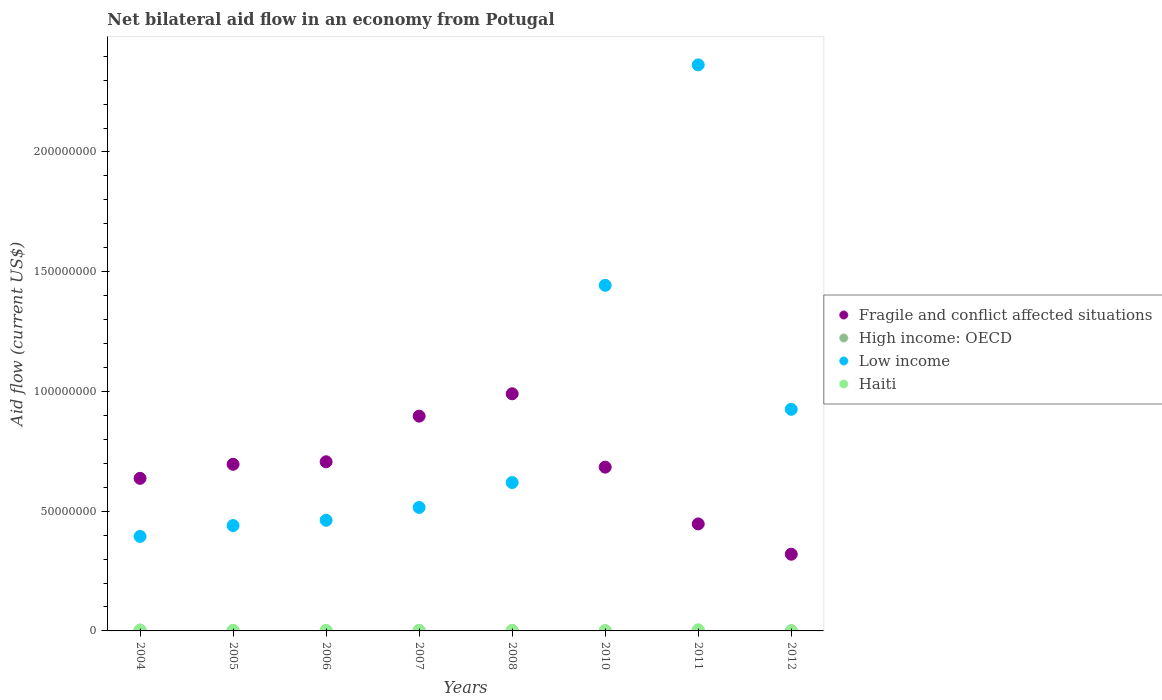How many different coloured dotlines are there?
Ensure brevity in your answer.  4. Is the number of dotlines equal to the number of legend labels?
Make the answer very short. Yes. What is the net bilateral aid flow in High income: OECD in 2008?
Provide a succinct answer. 1.00e+05. Across all years, what is the maximum net bilateral aid flow in Fragile and conflict affected situations?
Give a very brief answer. 9.90e+07. Across all years, what is the minimum net bilateral aid flow in Low income?
Offer a terse response. 3.94e+07. In which year was the net bilateral aid flow in Haiti maximum?
Your response must be concise. 2011. What is the total net bilateral aid flow in High income: OECD in the graph?
Offer a terse response. 9.10e+05. What is the difference between the net bilateral aid flow in Haiti in 2010 and that in 2011?
Ensure brevity in your answer.  -3.60e+05. What is the difference between the net bilateral aid flow in Low income in 2004 and the net bilateral aid flow in Fragile and conflict affected situations in 2005?
Offer a terse response. -3.01e+07. What is the average net bilateral aid flow in Fragile and conflict affected situations per year?
Provide a succinct answer. 6.72e+07. In the year 2011, what is the difference between the net bilateral aid flow in High income: OECD and net bilateral aid flow in Haiti?
Make the answer very short. -3.80e+05. In how many years, is the net bilateral aid flow in Low income greater than 140000000 US$?
Your response must be concise. 2. What is the ratio of the net bilateral aid flow in High income: OECD in 2004 to that in 2011?
Offer a terse response. 3.78. What is the difference between the highest and the second highest net bilateral aid flow in Fragile and conflict affected situations?
Your answer should be very brief. 9.33e+06. What is the difference between the highest and the lowest net bilateral aid flow in Low income?
Provide a short and direct response. 1.97e+08. In how many years, is the net bilateral aid flow in Low income greater than the average net bilateral aid flow in Low income taken over all years?
Provide a succinct answer. 3. Is the sum of the net bilateral aid flow in Haiti in 2010 and 2012 greater than the maximum net bilateral aid flow in Low income across all years?
Your response must be concise. No. Does the net bilateral aid flow in Haiti monotonically increase over the years?
Your answer should be compact. No. Is the net bilateral aid flow in Haiti strictly greater than the net bilateral aid flow in Fragile and conflict affected situations over the years?
Your response must be concise. No. How many dotlines are there?
Provide a short and direct response. 4. How many years are there in the graph?
Make the answer very short. 8. What is the difference between two consecutive major ticks on the Y-axis?
Your answer should be very brief. 5.00e+07. Are the values on the major ticks of Y-axis written in scientific E-notation?
Keep it short and to the point. No. Does the graph contain any zero values?
Your response must be concise. No. Where does the legend appear in the graph?
Ensure brevity in your answer.  Center right. What is the title of the graph?
Your answer should be very brief. Net bilateral aid flow in an economy from Potugal. What is the label or title of the Y-axis?
Offer a terse response. Aid flow (current US$). What is the Aid flow (current US$) in Fragile and conflict affected situations in 2004?
Keep it short and to the point. 6.37e+07. What is the Aid flow (current US$) in Low income in 2004?
Offer a very short reply. 3.94e+07. What is the Aid flow (current US$) in Fragile and conflict affected situations in 2005?
Provide a succinct answer. 6.96e+07. What is the Aid flow (current US$) in Low income in 2005?
Give a very brief answer. 4.40e+07. What is the Aid flow (current US$) in Fragile and conflict affected situations in 2006?
Your response must be concise. 7.06e+07. What is the Aid flow (current US$) in High income: OECD in 2006?
Offer a very short reply. 9.00e+04. What is the Aid flow (current US$) in Low income in 2006?
Provide a succinct answer. 4.62e+07. What is the Aid flow (current US$) in Fragile and conflict affected situations in 2007?
Your response must be concise. 8.97e+07. What is the Aid flow (current US$) in High income: OECD in 2007?
Your response must be concise. 1.30e+05. What is the Aid flow (current US$) in Low income in 2007?
Keep it short and to the point. 5.16e+07. What is the Aid flow (current US$) of Haiti in 2007?
Ensure brevity in your answer.  1.70e+05. What is the Aid flow (current US$) in Fragile and conflict affected situations in 2008?
Ensure brevity in your answer.  9.90e+07. What is the Aid flow (current US$) in Low income in 2008?
Provide a short and direct response. 6.20e+07. What is the Aid flow (current US$) in Haiti in 2008?
Offer a terse response. 1.80e+05. What is the Aid flow (current US$) in Fragile and conflict affected situations in 2010?
Offer a very short reply. 6.84e+07. What is the Aid flow (current US$) of Low income in 2010?
Make the answer very short. 1.44e+08. What is the Aid flow (current US$) in Haiti in 2010?
Make the answer very short. 1.10e+05. What is the Aid flow (current US$) in Fragile and conflict affected situations in 2011?
Keep it short and to the point. 4.47e+07. What is the Aid flow (current US$) of High income: OECD in 2011?
Your answer should be compact. 9.00e+04. What is the Aid flow (current US$) of Low income in 2011?
Ensure brevity in your answer.  2.36e+08. What is the Aid flow (current US$) in Fragile and conflict affected situations in 2012?
Keep it short and to the point. 3.20e+07. What is the Aid flow (current US$) of Low income in 2012?
Your response must be concise. 9.25e+07. What is the Aid flow (current US$) in Haiti in 2012?
Give a very brief answer. 10000. Across all years, what is the maximum Aid flow (current US$) in Fragile and conflict affected situations?
Offer a terse response. 9.90e+07. Across all years, what is the maximum Aid flow (current US$) in High income: OECD?
Make the answer very short. 3.40e+05. Across all years, what is the maximum Aid flow (current US$) in Low income?
Offer a very short reply. 2.36e+08. Across all years, what is the maximum Aid flow (current US$) of Haiti?
Ensure brevity in your answer.  4.70e+05. Across all years, what is the minimum Aid flow (current US$) in Fragile and conflict affected situations?
Offer a terse response. 3.20e+07. Across all years, what is the minimum Aid flow (current US$) of High income: OECD?
Your response must be concise. 4.00e+04. Across all years, what is the minimum Aid flow (current US$) in Low income?
Give a very brief answer. 3.94e+07. Across all years, what is the minimum Aid flow (current US$) in Haiti?
Make the answer very short. 10000. What is the total Aid flow (current US$) of Fragile and conflict affected situations in the graph?
Your response must be concise. 5.38e+08. What is the total Aid flow (current US$) of High income: OECD in the graph?
Your answer should be very brief. 9.10e+05. What is the total Aid flow (current US$) of Low income in the graph?
Offer a terse response. 7.16e+08. What is the total Aid flow (current US$) in Haiti in the graph?
Your answer should be compact. 1.64e+06. What is the difference between the Aid flow (current US$) of Fragile and conflict affected situations in 2004 and that in 2005?
Your answer should be compact. -5.87e+06. What is the difference between the Aid flow (current US$) in Low income in 2004 and that in 2005?
Your answer should be very brief. -4.55e+06. What is the difference between the Aid flow (current US$) of Haiti in 2004 and that in 2005?
Your response must be concise. 4.00e+04. What is the difference between the Aid flow (current US$) in Fragile and conflict affected situations in 2004 and that in 2006?
Offer a terse response. -6.92e+06. What is the difference between the Aid flow (current US$) of High income: OECD in 2004 and that in 2006?
Provide a succinct answer. 2.50e+05. What is the difference between the Aid flow (current US$) in Low income in 2004 and that in 2006?
Give a very brief answer. -6.76e+06. What is the difference between the Aid flow (current US$) of Fragile and conflict affected situations in 2004 and that in 2007?
Your answer should be very brief. -2.60e+07. What is the difference between the Aid flow (current US$) of High income: OECD in 2004 and that in 2007?
Provide a succinct answer. 2.10e+05. What is the difference between the Aid flow (current US$) in Low income in 2004 and that in 2007?
Give a very brief answer. -1.21e+07. What is the difference between the Aid flow (current US$) in Haiti in 2004 and that in 2007?
Give a very brief answer. 1.20e+05. What is the difference between the Aid flow (current US$) in Fragile and conflict affected situations in 2004 and that in 2008?
Offer a very short reply. -3.53e+07. What is the difference between the Aid flow (current US$) of High income: OECD in 2004 and that in 2008?
Offer a terse response. 2.40e+05. What is the difference between the Aid flow (current US$) in Low income in 2004 and that in 2008?
Offer a very short reply. -2.25e+07. What is the difference between the Aid flow (current US$) in Fragile and conflict affected situations in 2004 and that in 2010?
Ensure brevity in your answer.  -4.68e+06. What is the difference between the Aid flow (current US$) in High income: OECD in 2004 and that in 2010?
Provide a succinct answer. 3.00e+05. What is the difference between the Aid flow (current US$) in Low income in 2004 and that in 2010?
Ensure brevity in your answer.  -1.05e+08. What is the difference between the Aid flow (current US$) of Haiti in 2004 and that in 2010?
Your answer should be compact. 1.80e+05. What is the difference between the Aid flow (current US$) in Fragile and conflict affected situations in 2004 and that in 2011?
Make the answer very short. 1.90e+07. What is the difference between the Aid flow (current US$) of Low income in 2004 and that in 2011?
Offer a very short reply. -1.97e+08. What is the difference between the Aid flow (current US$) of Haiti in 2004 and that in 2011?
Offer a very short reply. -1.80e+05. What is the difference between the Aid flow (current US$) of Fragile and conflict affected situations in 2004 and that in 2012?
Provide a short and direct response. 3.17e+07. What is the difference between the Aid flow (current US$) of High income: OECD in 2004 and that in 2012?
Ensure brevity in your answer.  2.70e+05. What is the difference between the Aid flow (current US$) in Low income in 2004 and that in 2012?
Provide a succinct answer. -5.31e+07. What is the difference between the Aid flow (current US$) of Haiti in 2004 and that in 2012?
Your answer should be compact. 2.80e+05. What is the difference between the Aid flow (current US$) in Fragile and conflict affected situations in 2005 and that in 2006?
Make the answer very short. -1.05e+06. What is the difference between the Aid flow (current US$) of High income: OECD in 2005 and that in 2006?
Ensure brevity in your answer.  -4.00e+04. What is the difference between the Aid flow (current US$) of Low income in 2005 and that in 2006?
Offer a very short reply. -2.21e+06. What is the difference between the Aid flow (current US$) of Fragile and conflict affected situations in 2005 and that in 2007?
Give a very brief answer. -2.01e+07. What is the difference between the Aid flow (current US$) of Low income in 2005 and that in 2007?
Your answer should be compact. -7.56e+06. What is the difference between the Aid flow (current US$) in Haiti in 2005 and that in 2007?
Make the answer very short. 8.00e+04. What is the difference between the Aid flow (current US$) of Fragile and conflict affected situations in 2005 and that in 2008?
Provide a succinct answer. -2.94e+07. What is the difference between the Aid flow (current US$) of Low income in 2005 and that in 2008?
Your answer should be very brief. -1.80e+07. What is the difference between the Aid flow (current US$) in Haiti in 2005 and that in 2008?
Your answer should be very brief. 7.00e+04. What is the difference between the Aid flow (current US$) in Fragile and conflict affected situations in 2005 and that in 2010?
Give a very brief answer. 1.19e+06. What is the difference between the Aid flow (current US$) in Low income in 2005 and that in 2010?
Make the answer very short. -1.00e+08. What is the difference between the Aid flow (current US$) of Fragile and conflict affected situations in 2005 and that in 2011?
Keep it short and to the point. 2.49e+07. What is the difference between the Aid flow (current US$) of Low income in 2005 and that in 2011?
Offer a terse response. -1.92e+08. What is the difference between the Aid flow (current US$) in Fragile and conflict affected situations in 2005 and that in 2012?
Provide a succinct answer. 3.76e+07. What is the difference between the Aid flow (current US$) in Low income in 2005 and that in 2012?
Offer a very short reply. -4.85e+07. What is the difference between the Aid flow (current US$) in Haiti in 2005 and that in 2012?
Offer a very short reply. 2.40e+05. What is the difference between the Aid flow (current US$) in Fragile and conflict affected situations in 2006 and that in 2007?
Keep it short and to the point. -1.91e+07. What is the difference between the Aid flow (current US$) in High income: OECD in 2006 and that in 2007?
Keep it short and to the point. -4.00e+04. What is the difference between the Aid flow (current US$) in Low income in 2006 and that in 2007?
Offer a very short reply. -5.35e+06. What is the difference between the Aid flow (current US$) in Fragile and conflict affected situations in 2006 and that in 2008?
Your answer should be very brief. -2.84e+07. What is the difference between the Aid flow (current US$) in Low income in 2006 and that in 2008?
Give a very brief answer. -1.58e+07. What is the difference between the Aid flow (current US$) of Haiti in 2006 and that in 2008?
Your response must be concise. -2.00e+04. What is the difference between the Aid flow (current US$) in Fragile and conflict affected situations in 2006 and that in 2010?
Keep it short and to the point. 2.24e+06. What is the difference between the Aid flow (current US$) in High income: OECD in 2006 and that in 2010?
Provide a short and direct response. 5.00e+04. What is the difference between the Aid flow (current US$) in Low income in 2006 and that in 2010?
Ensure brevity in your answer.  -9.81e+07. What is the difference between the Aid flow (current US$) of Fragile and conflict affected situations in 2006 and that in 2011?
Your response must be concise. 2.60e+07. What is the difference between the Aid flow (current US$) in High income: OECD in 2006 and that in 2011?
Offer a very short reply. 0. What is the difference between the Aid flow (current US$) of Low income in 2006 and that in 2011?
Ensure brevity in your answer.  -1.90e+08. What is the difference between the Aid flow (current US$) in Haiti in 2006 and that in 2011?
Your response must be concise. -3.10e+05. What is the difference between the Aid flow (current US$) of Fragile and conflict affected situations in 2006 and that in 2012?
Keep it short and to the point. 3.86e+07. What is the difference between the Aid flow (current US$) of High income: OECD in 2006 and that in 2012?
Offer a very short reply. 2.00e+04. What is the difference between the Aid flow (current US$) of Low income in 2006 and that in 2012?
Give a very brief answer. -4.63e+07. What is the difference between the Aid flow (current US$) of Haiti in 2006 and that in 2012?
Ensure brevity in your answer.  1.50e+05. What is the difference between the Aid flow (current US$) of Fragile and conflict affected situations in 2007 and that in 2008?
Make the answer very short. -9.33e+06. What is the difference between the Aid flow (current US$) of Low income in 2007 and that in 2008?
Your response must be concise. -1.04e+07. What is the difference between the Aid flow (current US$) in Haiti in 2007 and that in 2008?
Provide a succinct answer. -10000. What is the difference between the Aid flow (current US$) of Fragile and conflict affected situations in 2007 and that in 2010?
Provide a succinct answer. 2.13e+07. What is the difference between the Aid flow (current US$) in Low income in 2007 and that in 2010?
Offer a very short reply. -9.28e+07. What is the difference between the Aid flow (current US$) of Fragile and conflict affected situations in 2007 and that in 2011?
Provide a succinct answer. 4.50e+07. What is the difference between the Aid flow (current US$) in Low income in 2007 and that in 2011?
Make the answer very short. -1.85e+08. What is the difference between the Aid flow (current US$) in Haiti in 2007 and that in 2011?
Offer a terse response. -3.00e+05. What is the difference between the Aid flow (current US$) in Fragile and conflict affected situations in 2007 and that in 2012?
Keep it short and to the point. 5.77e+07. What is the difference between the Aid flow (current US$) of Low income in 2007 and that in 2012?
Offer a very short reply. -4.10e+07. What is the difference between the Aid flow (current US$) in Fragile and conflict affected situations in 2008 and that in 2010?
Your answer should be very brief. 3.06e+07. What is the difference between the Aid flow (current US$) of Low income in 2008 and that in 2010?
Your answer should be compact. -8.23e+07. What is the difference between the Aid flow (current US$) in Haiti in 2008 and that in 2010?
Provide a succinct answer. 7.00e+04. What is the difference between the Aid flow (current US$) in Fragile and conflict affected situations in 2008 and that in 2011?
Ensure brevity in your answer.  5.43e+07. What is the difference between the Aid flow (current US$) in Low income in 2008 and that in 2011?
Make the answer very short. -1.74e+08. What is the difference between the Aid flow (current US$) in Fragile and conflict affected situations in 2008 and that in 2012?
Provide a succinct answer. 6.70e+07. What is the difference between the Aid flow (current US$) in Low income in 2008 and that in 2012?
Provide a short and direct response. -3.06e+07. What is the difference between the Aid flow (current US$) in Fragile and conflict affected situations in 2010 and that in 2011?
Keep it short and to the point. 2.37e+07. What is the difference between the Aid flow (current US$) in Low income in 2010 and that in 2011?
Make the answer very short. -9.20e+07. What is the difference between the Aid flow (current US$) in Haiti in 2010 and that in 2011?
Provide a succinct answer. -3.60e+05. What is the difference between the Aid flow (current US$) of Fragile and conflict affected situations in 2010 and that in 2012?
Provide a succinct answer. 3.64e+07. What is the difference between the Aid flow (current US$) in Low income in 2010 and that in 2012?
Your answer should be compact. 5.18e+07. What is the difference between the Aid flow (current US$) of Fragile and conflict affected situations in 2011 and that in 2012?
Keep it short and to the point. 1.26e+07. What is the difference between the Aid flow (current US$) of High income: OECD in 2011 and that in 2012?
Your response must be concise. 2.00e+04. What is the difference between the Aid flow (current US$) of Low income in 2011 and that in 2012?
Your answer should be compact. 1.44e+08. What is the difference between the Aid flow (current US$) in Fragile and conflict affected situations in 2004 and the Aid flow (current US$) in High income: OECD in 2005?
Give a very brief answer. 6.37e+07. What is the difference between the Aid flow (current US$) of Fragile and conflict affected situations in 2004 and the Aid flow (current US$) of Low income in 2005?
Your answer should be very brief. 1.97e+07. What is the difference between the Aid flow (current US$) in Fragile and conflict affected situations in 2004 and the Aid flow (current US$) in Haiti in 2005?
Provide a succinct answer. 6.35e+07. What is the difference between the Aid flow (current US$) in High income: OECD in 2004 and the Aid flow (current US$) in Low income in 2005?
Offer a terse response. -4.37e+07. What is the difference between the Aid flow (current US$) in High income: OECD in 2004 and the Aid flow (current US$) in Haiti in 2005?
Your response must be concise. 9.00e+04. What is the difference between the Aid flow (current US$) in Low income in 2004 and the Aid flow (current US$) in Haiti in 2005?
Provide a short and direct response. 3.92e+07. What is the difference between the Aid flow (current US$) of Fragile and conflict affected situations in 2004 and the Aid flow (current US$) of High income: OECD in 2006?
Offer a terse response. 6.36e+07. What is the difference between the Aid flow (current US$) in Fragile and conflict affected situations in 2004 and the Aid flow (current US$) in Low income in 2006?
Keep it short and to the point. 1.75e+07. What is the difference between the Aid flow (current US$) in Fragile and conflict affected situations in 2004 and the Aid flow (current US$) in Haiti in 2006?
Your response must be concise. 6.36e+07. What is the difference between the Aid flow (current US$) in High income: OECD in 2004 and the Aid flow (current US$) in Low income in 2006?
Give a very brief answer. -4.59e+07. What is the difference between the Aid flow (current US$) in Low income in 2004 and the Aid flow (current US$) in Haiti in 2006?
Provide a short and direct response. 3.93e+07. What is the difference between the Aid flow (current US$) of Fragile and conflict affected situations in 2004 and the Aid flow (current US$) of High income: OECD in 2007?
Make the answer very short. 6.36e+07. What is the difference between the Aid flow (current US$) of Fragile and conflict affected situations in 2004 and the Aid flow (current US$) of Low income in 2007?
Offer a very short reply. 1.22e+07. What is the difference between the Aid flow (current US$) of Fragile and conflict affected situations in 2004 and the Aid flow (current US$) of Haiti in 2007?
Offer a terse response. 6.35e+07. What is the difference between the Aid flow (current US$) in High income: OECD in 2004 and the Aid flow (current US$) in Low income in 2007?
Ensure brevity in your answer.  -5.12e+07. What is the difference between the Aid flow (current US$) in Low income in 2004 and the Aid flow (current US$) in Haiti in 2007?
Your answer should be very brief. 3.93e+07. What is the difference between the Aid flow (current US$) of Fragile and conflict affected situations in 2004 and the Aid flow (current US$) of High income: OECD in 2008?
Your response must be concise. 6.36e+07. What is the difference between the Aid flow (current US$) of Fragile and conflict affected situations in 2004 and the Aid flow (current US$) of Low income in 2008?
Your answer should be very brief. 1.73e+06. What is the difference between the Aid flow (current US$) of Fragile and conflict affected situations in 2004 and the Aid flow (current US$) of Haiti in 2008?
Give a very brief answer. 6.35e+07. What is the difference between the Aid flow (current US$) of High income: OECD in 2004 and the Aid flow (current US$) of Low income in 2008?
Your answer should be compact. -6.16e+07. What is the difference between the Aid flow (current US$) of High income: OECD in 2004 and the Aid flow (current US$) of Haiti in 2008?
Your answer should be very brief. 1.60e+05. What is the difference between the Aid flow (current US$) in Low income in 2004 and the Aid flow (current US$) in Haiti in 2008?
Your response must be concise. 3.93e+07. What is the difference between the Aid flow (current US$) of Fragile and conflict affected situations in 2004 and the Aid flow (current US$) of High income: OECD in 2010?
Offer a very short reply. 6.37e+07. What is the difference between the Aid flow (current US$) in Fragile and conflict affected situations in 2004 and the Aid flow (current US$) in Low income in 2010?
Offer a terse response. -8.06e+07. What is the difference between the Aid flow (current US$) in Fragile and conflict affected situations in 2004 and the Aid flow (current US$) in Haiti in 2010?
Make the answer very short. 6.36e+07. What is the difference between the Aid flow (current US$) in High income: OECD in 2004 and the Aid flow (current US$) in Low income in 2010?
Ensure brevity in your answer.  -1.44e+08. What is the difference between the Aid flow (current US$) of High income: OECD in 2004 and the Aid flow (current US$) of Haiti in 2010?
Give a very brief answer. 2.30e+05. What is the difference between the Aid flow (current US$) in Low income in 2004 and the Aid flow (current US$) in Haiti in 2010?
Keep it short and to the point. 3.93e+07. What is the difference between the Aid flow (current US$) in Fragile and conflict affected situations in 2004 and the Aid flow (current US$) in High income: OECD in 2011?
Offer a terse response. 6.36e+07. What is the difference between the Aid flow (current US$) of Fragile and conflict affected situations in 2004 and the Aid flow (current US$) of Low income in 2011?
Keep it short and to the point. -1.73e+08. What is the difference between the Aid flow (current US$) in Fragile and conflict affected situations in 2004 and the Aid flow (current US$) in Haiti in 2011?
Make the answer very short. 6.32e+07. What is the difference between the Aid flow (current US$) in High income: OECD in 2004 and the Aid flow (current US$) in Low income in 2011?
Provide a succinct answer. -2.36e+08. What is the difference between the Aid flow (current US$) in Low income in 2004 and the Aid flow (current US$) in Haiti in 2011?
Your answer should be compact. 3.90e+07. What is the difference between the Aid flow (current US$) in Fragile and conflict affected situations in 2004 and the Aid flow (current US$) in High income: OECD in 2012?
Offer a terse response. 6.36e+07. What is the difference between the Aid flow (current US$) in Fragile and conflict affected situations in 2004 and the Aid flow (current US$) in Low income in 2012?
Provide a short and direct response. -2.88e+07. What is the difference between the Aid flow (current US$) of Fragile and conflict affected situations in 2004 and the Aid flow (current US$) of Haiti in 2012?
Offer a very short reply. 6.37e+07. What is the difference between the Aid flow (current US$) of High income: OECD in 2004 and the Aid flow (current US$) of Low income in 2012?
Provide a succinct answer. -9.22e+07. What is the difference between the Aid flow (current US$) in Low income in 2004 and the Aid flow (current US$) in Haiti in 2012?
Give a very brief answer. 3.94e+07. What is the difference between the Aid flow (current US$) in Fragile and conflict affected situations in 2005 and the Aid flow (current US$) in High income: OECD in 2006?
Offer a terse response. 6.95e+07. What is the difference between the Aid flow (current US$) of Fragile and conflict affected situations in 2005 and the Aid flow (current US$) of Low income in 2006?
Provide a succinct answer. 2.34e+07. What is the difference between the Aid flow (current US$) of Fragile and conflict affected situations in 2005 and the Aid flow (current US$) of Haiti in 2006?
Your answer should be very brief. 6.94e+07. What is the difference between the Aid flow (current US$) of High income: OECD in 2005 and the Aid flow (current US$) of Low income in 2006?
Keep it short and to the point. -4.62e+07. What is the difference between the Aid flow (current US$) in Low income in 2005 and the Aid flow (current US$) in Haiti in 2006?
Offer a terse response. 4.38e+07. What is the difference between the Aid flow (current US$) of Fragile and conflict affected situations in 2005 and the Aid flow (current US$) of High income: OECD in 2007?
Your answer should be compact. 6.94e+07. What is the difference between the Aid flow (current US$) in Fragile and conflict affected situations in 2005 and the Aid flow (current US$) in Low income in 2007?
Give a very brief answer. 1.80e+07. What is the difference between the Aid flow (current US$) of Fragile and conflict affected situations in 2005 and the Aid flow (current US$) of Haiti in 2007?
Your response must be concise. 6.94e+07. What is the difference between the Aid flow (current US$) in High income: OECD in 2005 and the Aid flow (current US$) in Low income in 2007?
Offer a very short reply. -5.15e+07. What is the difference between the Aid flow (current US$) of High income: OECD in 2005 and the Aid flow (current US$) of Haiti in 2007?
Give a very brief answer. -1.20e+05. What is the difference between the Aid flow (current US$) of Low income in 2005 and the Aid flow (current US$) of Haiti in 2007?
Provide a short and direct response. 4.38e+07. What is the difference between the Aid flow (current US$) of Fragile and conflict affected situations in 2005 and the Aid flow (current US$) of High income: OECD in 2008?
Your answer should be very brief. 6.95e+07. What is the difference between the Aid flow (current US$) of Fragile and conflict affected situations in 2005 and the Aid flow (current US$) of Low income in 2008?
Your answer should be very brief. 7.60e+06. What is the difference between the Aid flow (current US$) of Fragile and conflict affected situations in 2005 and the Aid flow (current US$) of Haiti in 2008?
Your response must be concise. 6.94e+07. What is the difference between the Aid flow (current US$) in High income: OECD in 2005 and the Aid flow (current US$) in Low income in 2008?
Make the answer very short. -6.19e+07. What is the difference between the Aid flow (current US$) of High income: OECD in 2005 and the Aid flow (current US$) of Haiti in 2008?
Your response must be concise. -1.30e+05. What is the difference between the Aid flow (current US$) in Low income in 2005 and the Aid flow (current US$) in Haiti in 2008?
Provide a succinct answer. 4.38e+07. What is the difference between the Aid flow (current US$) of Fragile and conflict affected situations in 2005 and the Aid flow (current US$) of High income: OECD in 2010?
Offer a very short reply. 6.95e+07. What is the difference between the Aid flow (current US$) in Fragile and conflict affected situations in 2005 and the Aid flow (current US$) in Low income in 2010?
Your answer should be compact. -7.47e+07. What is the difference between the Aid flow (current US$) in Fragile and conflict affected situations in 2005 and the Aid flow (current US$) in Haiti in 2010?
Provide a succinct answer. 6.95e+07. What is the difference between the Aid flow (current US$) of High income: OECD in 2005 and the Aid flow (current US$) of Low income in 2010?
Give a very brief answer. -1.44e+08. What is the difference between the Aid flow (current US$) in High income: OECD in 2005 and the Aid flow (current US$) in Haiti in 2010?
Offer a very short reply. -6.00e+04. What is the difference between the Aid flow (current US$) of Low income in 2005 and the Aid flow (current US$) of Haiti in 2010?
Provide a succinct answer. 4.39e+07. What is the difference between the Aid flow (current US$) of Fragile and conflict affected situations in 2005 and the Aid flow (current US$) of High income: OECD in 2011?
Your response must be concise. 6.95e+07. What is the difference between the Aid flow (current US$) of Fragile and conflict affected situations in 2005 and the Aid flow (current US$) of Low income in 2011?
Your answer should be very brief. -1.67e+08. What is the difference between the Aid flow (current US$) in Fragile and conflict affected situations in 2005 and the Aid flow (current US$) in Haiti in 2011?
Your answer should be compact. 6.91e+07. What is the difference between the Aid flow (current US$) of High income: OECD in 2005 and the Aid flow (current US$) of Low income in 2011?
Your answer should be very brief. -2.36e+08. What is the difference between the Aid flow (current US$) of High income: OECD in 2005 and the Aid flow (current US$) of Haiti in 2011?
Your answer should be compact. -4.20e+05. What is the difference between the Aid flow (current US$) of Low income in 2005 and the Aid flow (current US$) of Haiti in 2011?
Your answer should be compact. 4.35e+07. What is the difference between the Aid flow (current US$) in Fragile and conflict affected situations in 2005 and the Aid flow (current US$) in High income: OECD in 2012?
Provide a short and direct response. 6.95e+07. What is the difference between the Aid flow (current US$) in Fragile and conflict affected situations in 2005 and the Aid flow (current US$) in Low income in 2012?
Your response must be concise. -2.30e+07. What is the difference between the Aid flow (current US$) of Fragile and conflict affected situations in 2005 and the Aid flow (current US$) of Haiti in 2012?
Make the answer very short. 6.96e+07. What is the difference between the Aid flow (current US$) of High income: OECD in 2005 and the Aid flow (current US$) of Low income in 2012?
Make the answer very short. -9.25e+07. What is the difference between the Aid flow (current US$) in Low income in 2005 and the Aid flow (current US$) in Haiti in 2012?
Provide a short and direct response. 4.40e+07. What is the difference between the Aid flow (current US$) in Fragile and conflict affected situations in 2006 and the Aid flow (current US$) in High income: OECD in 2007?
Offer a terse response. 7.05e+07. What is the difference between the Aid flow (current US$) in Fragile and conflict affected situations in 2006 and the Aid flow (current US$) in Low income in 2007?
Give a very brief answer. 1.91e+07. What is the difference between the Aid flow (current US$) in Fragile and conflict affected situations in 2006 and the Aid flow (current US$) in Haiti in 2007?
Your answer should be very brief. 7.05e+07. What is the difference between the Aid flow (current US$) in High income: OECD in 2006 and the Aid flow (current US$) in Low income in 2007?
Give a very brief answer. -5.15e+07. What is the difference between the Aid flow (current US$) in High income: OECD in 2006 and the Aid flow (current US$) in Haiti in 2007?
Ensure brevity in your answer.  -8.00e+04. What is the difference between the Aid flow (current US$) in Low income in 2006 and the Aid flow (current US$) in Haiti in 2007?
Your answer should be compact. 4.60e+07. What is the difference between the Aid flow (current US$) of Fragile and conflict affected situations in 2006 and the Aid flow (current US$) of High income: OECD in 2008?
Make the answer very short. 7.05e+07. What is the difference between the Aid flow (current US$) in Fragile and conflict affected situations in 2006 and the Aid flow (current US$) in Low income in 2008?
Your answer should be very brief. 8.65e+06. What is the difference between the Aid flow (current US$) in Fragile and conflict affected situations in 2006 and the Aid flow (current US$) in Haiti in 2008?
Offer a very short reply. 7.04e+07. What is the difference between the Aid flow (current US$) in High income: OECD in 2006 and the Aid flow (current US$) in Low income in 2008?
Provide a succinct answer. -6.19e+07. What is the difference between the Aid flow (current US$) in High income: OECD in 2006 and the Aid flow (current US$) in Haiti in 2008?
Provide a short and direct response. -9.00e+04. What is the difference between the Aid flow (current US$) in Low income in 2006 and the Aid flow (current US$) in Haiti in 2008?
Make the answer very short. 4.60e+07. What is the difference between the Aid flow (current US$) of Fragile and conflict affected situations in 2006 and the Aid flow (current US$) of High income: OECD in 2010?
Provide a succinct answer. 7.06e+07. What is the difference between the Aid flow (current US$) in Fragile and conflict affected situations in 2006 and the Aid flow (current US$) in Low income in 2010?
Your answer should be compact. -7.37e+07. What is the difference between the Aid flow (current US$) in Fragile and conflict affected situations in 2006 and the Aid flow (current US$) in Haiti in 2010?
Offer a terse response. 7.05e+07. What is the difference between the Aid flow (current US$) of High income: OECD in 2006 and the Aid flow (current US$) of Low income in 2010?
Provide a short and direct response. -1.44e+08. What is the difference between the Aid flow (current US$) in Low income in 2006 and the Aid flow (current US$) in Haiti in 2010?
Give a very brief answer. 4.61e+07. What is the difference between the Aid flow (current US$) in Fragile and conflict affected situations in 2006 and the Aid flow (current US$) in High income: OECD in 2011?
Offer a very short reply. 7.05e+07. What is the difference between the Aid flow (current US$) in Fragile and conflict affected situations in 2006 and the Aid flow (current US$) in Low income in 2011?
Keep it short and to the point. -1.66e+08. What is the difference between the Aid flow (current US$) of Fragile and conflict affected situations in 2006 and the Aid flow (current US$) of Haiti in 2011?
Provide a short and direct response. 7.02e+07. What is the difference between the Aid flow (current US$) in High income: OECD in 2006 and the Aid flow (current US$) in Low income in 2011?
Your answer should be compact. -2.36e+08. What is the difference between the Aid flow (current US$) in High income: OECD in 2006 and the Aid flow (current US$) in Haiti in 2011?
Make the answer very short. -3.80e+05. What is the difference between the Aid flow (current US$) in Low income in 2006 and the Aid flow (current US$) in Haiti in 2011?
Provide a short and direct response. 4.57e+07. What is the difference between the Aid flow (current US$) in Fragile and conflict affected situations in 2006 and the Aid flow (current US$) in High income: OECD in 2012?
Your answer should be compact. 7.06e+07. What is the difference between the Aid flow (current US$) of Fragile and conflict affected situations in 2006 and the Aid flow (current US$) of Low income in 2012?
Your response must be concise. -2.19e+07. What is the difference between the Aid flow (current US$) of Fragile and conflict affected situations in 2006 and the Aid flow (current US$) of Haiti in 2012?
Keep it short and to the point. 7.06e+07. What is the difference between the Aid flow (current US$) in High income: OECD in 2006 and the Aid flow (current US$) in Low income in 2012?
Make the answer very short. -9.24e+07. What is the difference between the Aid flow (current US$) of Low income in 2006 and the Aid flow (current US$) of Haiti in 2012?
Keep it short and to the point. 4.62e+07. What is the difference between the Aid flow (current US$) in Fragile and conflict affected situations in 2007 and the Aid flow (current US$) in High income: OECD in 2008?
Offer a very short reply. 8.96e+07. What is the difference between the Aid flow (current US$) in Fragile and conflict affected situations in 2007 and the Aid flow (current US$) in Low income in 2008?
Provide a short and direct response. 2.77e+07. What is the difference between the Aid flow (current US$) in Fragile and conflict affected situations in 2007 and the Aid flow (current US$) in Haiti in 2008?
Keep it short and to the point. 8.95e+07. What is the difference between the Aid flow (current US$) in High income: OECD in 2007 and the Aid flow (current US$) in Low income in 2008?
Provide a succinct answer. -6.18e+07. What is the difference between the Aid flow (current US$) in Low income in 2007 and the Aid flow (current US$) in Haiti in 2008?
Ensure brevity in your answer.  5.14e+07. What is the difference between the Aid flow (current US$) in Fragile and conflict affected situations in 2007 and the Aid flow (current US$) in High income: OECD in 2010?
Your answer should be very brief. 8.96e+07. What is the difference between the Aid flow (current US$) of Fragile and conflict affected situations in 2007 and the Aid flow (current US$) of Low income in 2010?
Provide a succinct answer. -5.46e+07. What is the difference between the Aid flow (current US$) in Fragile and conflict affected situations in 2007 and the Aid flow (current US$) in Haiti in 2010?
Make the answer very short. 8.96e+07. What is the difference between the Aid flow (current US$) of High income: OECD in 2007 and the Aid flow (current US$) of Low income in 2010?
Your answer should be very brief. -1.44e+08. What is the difference between the Aid flow (current US$) in High income: OECD in 2007 and the Aid flow (current US$) in Haiti in 2010?
Your answer should be very brief. 2.00e+04. What is the difference between the Aid flow (current US$) of Low income in 2007 and the Aid flow (current US$) of Haiti in 2010?
Provide a short and direct response. 5.14e+07. What is the difference between the Aid flow (current US$) of Fragile and conflict affected situations in 2007 and the Aid flow (current US$) of High income: OECD in 2011?
Provide a short and direct response. 8.96e+07. What is the difference between the Aid flow (current US$) of Fragile and conflict affected situations in 2007 and the Aid flow (current US$) of Low income in 2011?
Your answer should be compact. -1.47e+08. What is the difference between the Aid flow (current US$) in Fragile and conflict affected situations in 2007 and the Aid flow (current US$) in Haiti in 2011?
Provide a succinct answer. 8.92e+07. What is the difference between the Aid flow (current US$) of High income: OECD in 2007 and the Aid flow (current US$) of Low income in 2011?
Offer a very short reply. -2.36e+08. What is the difference between the Aid flow (current US$) of High income: OECD in 2007 and the Aid flow (current US$) of Haiti in 2011?
Provide a succinct answer. -3.40e+05. What is the difference between the Aid flow (current US$) in Low income in 2007 and the Aid flow (current US$) in Haiti in 2011?
Offer a terse response. 5.11e+07. What is the difference between the Aid flow (current US$) of Fragile and conflict affected situations in 2007 and the Aid flow (current US$) of High income: OECD in 2012?
Offer a very short reply. 8.96e+07. What is the difference between the Aid flow (current US$) of Fragile and conflict affected situations in 2007 and the Aid flow (current US$) of Low income in 2012?
Your answer should be very brief. -2.85e+06. What is the difference between the Aid flow (current US$) in Fragile and conflict affected situations in 2007 and the Aid flow (current US$) in Haiti in 2012?
Your answer should be compact. 8.97e+07. What is the difference between the Aid flow (current US$) of High income: OECD in 2007 and the Aid flow (current US$) of Low income in 2012?
Keep it short and to the point. -9.24e+07. What is the difference between the Aid flow (current US$) of High income: OECD in 2007 and the Aid flow (current US$) of Haiti in 2012?
Provide a succinct answer. 1.20e+05. What is the difference between the Aid flow (current US$) in Low income in 2007 and the Aid flow (current US$) in Haiti in 2012?
Your answer should be compact. 5.16e+07. What is the difference between the Aid flow (current US$) of Fragile and conflict affected situations in 2008 and the Aid flow (current US$) of High income: OECD in 2010?
Offer a very short reply. 9.90e+07. What is the difference between the Aid flow (current US$) in Fragile and conflict affected situations in 2008 and the Aid flow (current US$) in Low income in 2010?
Your response must be concise. -4.53e+07. What is the difference between the Aid flow (current US$) in Fragile and conflict affected situations in 2008 and the Aid flow (current US$) in Haiti in 2010?
Your answer should be compact. 9.89e+07. What is the difference between the Aid flow (current US$) of High income: OECD in 2008 and the Aid flow (current US$) of Low income in 2010?
Make the answer very short. -1.44e+08. What is the difference between the Aid flow (current US$) of Low income in 2008 and the Aid flow (current US$) of Haiti in 2010?
Make the answer very short. 6.19e+07. What is the difference between the Aid flow (current US$) of Fragile and conflict affected situations in 2008 and the Aid flow (current US$) of High income: OECD in 2011?
Your response must be concise. 9.89e+07. What is the difference between the Aid flow (current US$) of Fragile and conflict affected situations in 2008 and the Aid flow (current US$) of Low income in 2011?
Offer a terse response. -1.37e+08. What is the difference between the Aid flow (current US$) in Fragile and conflict affected situations in 2008 and the Aid flow (current US$) in Haiti in 2011?
Offer a terse response. 9.86e+07. What is the difference between the Aid flow (current US$) in High income: OECD in 2008 and the Aid flow (current US$) in Low income in 2011?
Offer a very short reply. -2.36e+08. What is the difference between the Aid flow (current US$) in High income: OECD in 2008 and the Aid flow (current US$) in Haiti in 2011?
Keep it short and to the point. -3.70e+05. What is the difference between the Aid flow (current US$) in Low income in 2008 and the Aid flow (current US$) in Haiti in 2011?
Keep it short and to the point. 6.15e+07. What is the difference between the Aid flow (current US$) of Fragile and conflict affected situations in 2008 and the Aid flow (current US$) of High income: OECD in 2012?
Your answer should be compact. 9.90e+07. What is the difference between the Aid flow (current US$) of Fragile and conflict affected situations in 2008 and the Aid flow (current US$) of Low income in 2012?
Provide a short and direct response. 6.48e+06. What is the difference between the Aid flow (current US$) in Fragile and conflict affected situations in 2008 and the Aid flow (current US$) in Haiti in 2012?
Your answer should be compact. 9.90e+07. What is the difference between the Aid flow (current US$) in High income: OECD in 2008 and the Aid flow (current US$) in Low income in 2012?
Offer a very short reply. -9.24e+07. What is the difference between the Aid flow (current US$) of High income: OECD in 2008 and the Aid flow (current US$) of Haiti in 2012?
Your answer should be very brief. 9.00e+04. What is the difference between the Aid flow (current US$) in Low income in 2008 and the Aid flow (current US$) in Haiti in 2012?
Give a very brief answer. 6.20e+07. What is the difference between the Aid flow (current US$) of Fragile and conflict affected situations in 2010 and the Aid flow (current US$) of High income: OECD in 2011?
Your answer should be very brief. 6.83e+07. What is the difference between the Aid flow (current US$) in Fragile and conflict affected situations in 2010 and the Aid flow (current US$) in Low income in 2011?
Offer a terse response. -1.68e+08. What is the difference between the Aid flow (current US$) of Fragile and conflict affected situations in 2010 and the Aid flow (current US$) of Haiti in 2011?
Your answer should be compact. 6.79e+07. What is the difference between the Aid flow (current US$) of High income: OECD in 2010 and the Aid flow (current US$) of Low income in 2011?
Give a very brief answer. -2.36e+08. What is the difference between the Aid flow (current US$) in High income: OECD in 2010 and the Aid flow (current US$) in Haiti in 2011?
Your answer should be compact. -4.30e+05. What is the difference between the Aid flow (current US$) in Low income in 2010 and the Aid flow (current US$) in Haiti in 2011?
Keep it short and to the point. 1.44e+08. What is the difference between the Aid flow (current US$) in Fragile and conflict affected situations in 2010 and the Aid flow (current US$) in High income: OECD in 2012?
Ensure brevity in your answer.  6.83e+07. What is the difference between the Aid flow (current US$) in Fragile and conflict affected situations in 2010 and the Aid flow (current US$) in Low income in 2012?
Your response must be concise. -2.42e+07. What is the difference between the Aid flow (current US$) in Fragile and conflict affected situations in 2010 and the Aid flow (current US$) in Haiti in 2012?
Give a very brief answer. 6.84e+07. What is the difference between the Aid flow (current US$) of High income: OECD in 2010 and the Aid flow (current US$) of Low income in 2012?
Give a very brief answer. -9.25e+07. What is the difference between the Aid flow (current US$) of High income: OECD in 2010 and the Aid flow (current US$) of Haiti in 2012?
Ensure brevity in your answer.  3.00e+04. What is the difference between the Aid flow (current US$) in Low income in 2010 and the Aid flow (current US$) in Haiti in 2012?
Give a very brief answer. 1.44e+08. What is the difference between the Aid flow (current US$) in Fragile and conflict affected situations in 2011 and the Aid flow (current US$) in High income: OECD in 2012?
Provide a short and direct response. 4.46e+07. What is the difference between the Aid flow (current US$) of Fragile and conflict affected situations in 2011 and the Aid flow (current US$) of Low income in 2012?
Your response must be concise. -4.79e+07. What is the difference between the Aid flow (current US$) in Fragile and conflict affected situations in 2011 and the Aid flow (current US$) in Haiti in 2012?
Keep it short and to the point. 4.47e+07. What is the difference between the Aid flow (current US$) of High income: OECD in 2011 and the Aid flow (current US$) of Low income in 2012?
Your answer should be compact. -9.24e+07. What is the difference between the Aid flow (current US$) in High income: OECD in 2011 and the Aid flow (current US$) in Haiti in 2012?
Your answer should be compact. 8.00e+04. What is the difference between the Aid flow (current US$) of Low income in 2011 and the Aid flow (current US$) of Haiti in 2012?
Your response must be concise. 2.36e+08. What is the average Aid flow (current US$) in Fragile and conflict affected situations per year?
Provide a short and direct response. 6.72e+07. What is the average Aid flow (current US$) in High income: OECD per year?
Give a very brief answer. 1.14e+05. What is the average Aid flow (current US$) of Low income per year?
Make the answer very short. 8.96e+07. What is the average Aid flow (current US$) in Haiti per year?
Your answer should be very brief. 2.05e+05. In the year 2004, what is the difference between the Aid flow (current US$) of Fragile and conflict affected situations and Aid flow (current US$) of High income: OECD?
Provide a succinct answer. 6.34e+07. In the year 2004, what is the difference between the Aid flow (current US$) of Fragile and conflict affected situations and Aid flow (current US$) of Low income?
Your response must be concise. 2.43e+07. In the year 2004, what is the difference between the Aid flow (current US$) in Fragile and conflict affected situations and Aid flow (current US$) in Haiti?
Offer a terse response. 6.34e+07. In the year 2004, what is the difference between the Aid flow (current US$) of High income: OECD and Aid flow (current US$) of Low income?
Your answer should be compact. -3.91e+07. In the year 2004, what is the difference between the Aid flow (current US$) of Low income and Aid flow (current US$) of Haiti?
Provide a short and direct response. 3.92e+07. In the year 2005, what is the difference between the Aid flow (current US$) in Fragile and conflict affected situations and Aid flow (current US$) in High income: OECD?
Offer a very short reply. 6.95e+07. In the year 2005, what is the difference between the Aid flow (current US$) of Fragile and conflict affected situations and Aid flow (current US$) of Low income?
Your answer should be very brief. 2.56e+07. In the year 2005, what is the difference between the Aid flow (current US$) of Fragile and conflict affected situations and Aid flow (current US$) of Haiti?
Offer a very short reply. 6.93e+07. In the year 2005, what is the difference between the Aid flow (current US$) of High income: OECD and Aid flow (current US$) of Low income?
Provide a succinct answer. -4.40e+07. In the year 2005, what is the difference between the Aid flow (current US$) of Low income and Aid flow (current US$) of Haiti?
Ensure brevity in your answer.  4.38e+07. In the year 2006, what is the difference between the Aid flow (current US$) in Fragile and conflict affected situations and Aid flow (current US$) in High income: OECD?
Your response must be concise. 7.05e+07. In the year 2006, what is the difference between the Aid flow (current US$) in Fragile and conflict affected situations and Aid flow (current US$) in Low income?
Keep it short and to the point. 2.44e+07. In the year 2006, what is the difference between the Aid flow (current US$) of Fragile and conflict affected situations and Aid flow (current US$) of Haiti?
Offer a very short reply. 7.05e+07. In the year 2006, what is the difference between the Aid flow (current US$) of High income: OECD and Aid flow (current US$) of Low income?
Give a very brief answer. -4.61e+07. In the year 2006, what is the difference between the Aid flow (current US$) of High income: OECD and Aid flow (current US$) of Haiti?
Your answer should be compact. -7.00e+04. In the year 2006, what is the difference between the Aid flow (current US$) of Low income and Aid flow (current US$) of Haiti?
Provide a succinct answer. 4.60e+07. In the year 2007, what is the difference between the Aid flow (current US$) in Fragile and conflict affected situations and Aid flow (current US$) in High income: OECD?
Give a very brief answer. 8.96e+07. In the year 2007, what is the difference between the Aid flow (current US$) of Fragile and conflict affected situations and Aid flow (current US$) of Low income?
Your answer should be compact. 3.81e+07. In the year 2007, what is the difference between the Aid flow (current US$) of Fragile and conflict affected situations and Aid flow (current US$) of Haiti?
Give a very brief answer. 8.95e+07. In the year 2007, what is the difference between the Aid flow (current US$) of High income: OECD and Aid flow (current US$) of Low income?
Make the answer very short. -5.14e+07. In the year 2007, what is the difference between the Aid flow (current US$) in Low income and Aid flow (current US$) in Haiti?
Provide a short and direct response. 5.14e+07. In the year 2008, what is the difference between the Aid flow (current US$) of Fragile and conflict affected situations and Aid flow (current US$) of High income: OECD?
Provide a short and direct response. 9.89e+07. In the year 2008, what is the difference between the Aid flow (current US$) in Fragile and conflict affected situations and Aid flow (current US$) in Low income?
Give a very brief answer. 3.70e+07. In the year 2008, what is the difference between the Aid flow (current US$) of Fragile and conflict affected situations and Aid flow (current US$) of Haiti?
Provide a short and direct response. 9.88e+07. In the year 2008, what is the difference between the Aid flow (current US$) in High income: OECD and Aid flow (current US$) in Low income?
Your answer should be very brief. -6.19e+07. In the year 2008, what is the difference between the Aid flow (current US$) in Low income and Aid flow (current US$) in Haiti?
Keep it short and to the point. 6.18e+07. In the year 2010, what is the difference between the Aid flow (current US$) of Fragile and conflict affected situations and Aid flow (current US$) of High income: OECD?
Offer a terse response. 6.84e+07. In the year 2010, what is the difference between the Aid flow (current US$) in Fragile and conflict affected situations and Aid flow (current US$) in Low income?
Give a very brief answer. -7.59e+07. In the year 2010, what is the difference between the Aid flow (current US$) of Fragile and conflict affected situations and Aid flow (current US$) of Haiti?
Make the answer very short. 6.83e+07. In the year 2010, what is the difference between the Aid flow (current US$) in High income: OECD and Aid flow (current US$) in Low income?
Give a very brief answer. -1.44e+08. In the year 2010, what is the difference between the Aid flow (current US$) of High income: OECD and Aid flow (current US$) of Haiti?
Make the answer very short. -7.00e+04. In the year 2010, what is the difference between the Aid flow (current US$) of Low income and Aid flow (current US$) of Haiti?
Your response must be concise. 1.44e+08. In the year 2011, what is the difference between the Aid flow (current US$) in Fragile and conflict affected situations and Aid flow (current US$) in High income: OECD?
Offer a terse response. 4.46e+07. In the year 2011, what is the difference between the Aid flow (current US$) of Fragile and conflict affected situations and Aid flow (current US$) of Low income?
Your answer should be very brief. -1.92e+08. In the year 2011, what is the difference between the Aid flow (current US$) in Fragile and conflict affected situations and Aid flow (current US$) in Haiti?
Make the answer very short. 4.42e+07. In the year 2011, what is the difference between the Aid flow (current US$) in High income: OECD and Aid flow (current US$) in Low income?
Make the answer very short. -2.36e+08. In the year 2011, what is the difference between the Aid flow (current US$) of High income: OECD and Aid flow (current US$) of Haiti?
Your answer should be compact. -3.80e+05. In the year 2011, what is the difference between the Aid flow (current US$) in Low income and Aid flow (current US$) in Haiti?
Ensure brevity in your answer.  2.36e+08. In the year 2012, what is the difference between the Aid flow (current US$) in Fragile and conflict affected situations and Aid flow (current US$) in High income: OECD?
Make the answer very short. 3.20e+07. In the year 2012, what is the difference between the Aid flow (current US$) of Fragile and conflict affected situations and Aid flow (current US$) of Low income?
Make the answer very short. -6.05e+07. In the year 2012, what is the difference between the Aid flow (current US$) of Fragile and conflict affected situations and Aid flow (current US$) of Haiti?
Ensure brevity in your answer.  3.20e+07. In the year 2012, what is the difference between the Aid flow (current US$) of High income: OECD and Aid flow (current US$) of Low income?
Make the answer very short. -9.25e+07. In the year 2012, what is the difference between the Aid flow (current US$) in Low income and Aid flow (current US$) in Haiti?
Keep it short and to the point. 9.25e+07. What is the ratio of the Aid flow (current US$) of Fragile and conflict affected situations in 2004 to that in 2005?
Your answer should be very brief. 0.92. What is the ratio of the Aid flow (current US$) in Low income in 2004 to that in 2005?
Provide a succinct answer. 0.9. What is the ratio of the Aid flow (current US$) in Haiti in 2004 to that in 2005?
Keep it short and to the point. 1.16. What is the ratio of the Aid flow (current US$) in Fragile and conflict affected situations in 2004 to that in 2006?
Your answer should be compact. 0.9. What is the ratio of the Aid flow (current US$) in High income: OECD in 2004 to that in 2006?
Keep it short and to the point. 3.78. What is the ratio of the Aid flow (current US$) in Low income in 2004 to that in 2006?
Offer a very short reply. 0.85. What is the ratio of the Aid flow (current US$) of Haiti in 2004 to that in 2006?
Your answer should be very brief. 1.81. What is the ratio of the Aid flow (current US$) of Fragile and conflict affected situations in 2004 to that in 2007?
Provide a short and direct response. 0.71. What is the ratio of the Aid flow (current US$) in High income: OECD in 2004 to that in 2007?
Keep it short and to the point. 2.62. What is the ratio of the Aid flow (current US$) of Low income in 2004 to that in 2007?
Your answer should be compact. 0.77. What is the ratio of the Aid flow (current US$) of Haiti in 2004 to that in 2007?
Make the answer very short. 1.71. What is the ratio of the Aid flow (current US$) of Fragile and conflict affected situations in 2004 to that in 2008?
Your answer should be compact. 0.64. What is the ratio of the Aid flow (current US$) in High income: OECD in 2004 to that in 2008?
Your response must be concise. 3.4. What is the ratio of the Aid flow (current US$) of Low income in 2004 to that in 2008?
Your answer should be compact. 0.64. What is the ratio of the Aid flow (current US$) in Haiti in 2004 to that in 2008?
Offer a terse response. 1.61. What is the ratio of the Aid flow (current US$) in Fragile and conflict affected situations in 2004 to that in 2010?
Keep it short and to the point. 0.93. What is the ratio of the Aid flow (current US$) in Low income in 2004 to that in 2010?
Your answer should be very brief. 0.27. What is the ratio of the Aid flow (current US$) of Haiti in 2004 to that in 2010?
Keep it short and to the point. 2.64. What is the ratio of the Aid flow (current US$) of Fragile and conflict affected situations in 2004 to that in 2011?
Your answer should be compact. 1.43. What is the ratio of the Aid flow (current US$) of High income: OECD in 2004 to that in 2011?
Keep it short and to the point. 3.78. What is the ratio of the Aid flow (current US$) of Low income in 2004 to that in 2011?
Offer a terse response. 0.17. What is the ratio of the Aid flow (current US$) in Haiti in 2004 to that in 2011?
Keep it short and to the point. 0.62. What is the ratio of the Aid flow (current US$) of Fragile and conflict affected situations in 2004 to that in 2012?
Offer a terse response. 1.99. What is the ratio of the Aid flow (current US$) in High income: OECD in 2004 to that in 2012?
Keep it short and to the point. 4.86. What is the ratio of the Aid flow (current US$) of Low income in 2004 to that in 2012?
Give a very brief answer. 0.43. What is the ratio of the Aid flow (current US$) in Fragile and conflict affected situations in 2005 to that in 2006?
Ensure brevity in your answer.  0.99. What is the ratio of the Aid flow (current US$) in High income: OECD in 2005 to that in 2006?
Ensure brevity in your answer.  0.56. What is the ratio of the Aid flow (current US$) of Low income in 2005 to that in 2006?
Make the answer very short. 0.95. What is the ratio of the Aid flow (current US$) in Haiti in 2005 to that in 2006?
Your response must be concise. 1.56. What is the ratio of the Aid flow (current US$) in Fragile and conflict affected situations in 2005 to that in 2007?
Your answer should be very brief. 0.78. What is the ratio of the Aid flow (current US$) of High income: OECD in 2005 to that in 2007?
Give a very brief answer. 0.38. What is the ratio of the Aid flow (current US$) in Low income in 2005 to that in 2007?
Your response must be concise. 0.85. What is the ratio of the Aid flow (current US$) in Haiti in 2005 to that in 2007?
Your answer should be very brief. 1.47. What is the ratio of the Aid flow (current US$) of Fragile and conflict affected situations in 2005 to that in 2008?
Offer a terse response. 0.7. What is the ratio of the Aid flow (current US$) in Low income in 2005 to that in 2008?
Provide a short and direct response. 0.71. What is the ratio of the Aid flow (current US$) of Haiti in 2005 to that in 2008?
Provide a short and direct response. 1.39. What is the ratio of the Aid flow (current US$) in Fragile and conflict affected situations in 2005 to that in 2010?
Make the answer very short. 1.02. What is the ratio of the Aid flow (current US$) of Low income in 2005 to that in 2010?
Provide a succinct answer. 0.3. What is the ratio of the Aid flow (current US$) of Haiti in 2005 to that in 2010?
Give a very brief answer. 2.27. What is the ratio of the Aid flow (current US$) of Fragile and conflict affected situations in 2005 to that in 2011?
Your response must be concise. 1.56. What is the ratio of the Aid flow (current US$) of High income: OECD in 2005 to that in 2011?
Your response must be concise. 0.56. What is the ratio of the Aid flow (current US$) in Low income in 2005 to that in 2011?
Give a very brief answer. 0.19. What is the ratio of the Aid flow (current US$) of Haiti in 2005 to that in 2011?
Your response must be concise. 0.53. What is the ratio of the Aid flow (current US$) of Fragile and conflict affected situations in 2005 to that in 2012?
Your answer should be compact. 2.17. What is the ratio of the Aid flow (current US$) of High income: OECD in 2005 to that in 2012?
Offer a very short reply. 0.71. What is the ratio of the Aid flow (current US$) in Low income in 2005 to that in 2012?
Give a very brief answer. 0.48. What is the ratio of the Aid flow (current US$) of Haiti in 2005 to that in 2012?
Provide a succinct answer. 25. What is the ratio of the Aid flow (current US$) of Fragile and conflict affected situations in 2006 to that in 2007?
Provide a succinct answer. 0.79. What is the ratio of the Aid flow (current US$) in High income: OECD in 2006 to that in 2007?
Offer a terse response. 0.69. What is the ratio of the Aid flow (current US$) of Low income in 2006 to that in 2007?
Your answer should be compact. 0.9. What is the ratio of the Aid flow (current US$) in Fragile and conflict affected situations in 2006 to that in 2008?
Make the answer very short. 0.71. What is the ratio of the Aid flow (current US$) of High income: OECD in 2006 to that in 2008?
Offer a terse response. 0.9. What is the ratio of the Aid flow (current US$) of Low income in 2006 to that in 2008?
Keep it short and to the point. 0.75. What is the ratio of the Aid flow (current US$) of Haiti in 2006 to that in 2008?
Give a very brief answer. 0.89. What is the ratio of the Aid flow (current US$) of Fragile and conflict affected situations in 2006 to that in 2010?
Your answer should be compact. 1.03. What is the ratio of the Aid flow (current US$) of High income: OECD in 2006 to that in 2010?
Offer a terse response. 2.25. What is the ratio of the Aid flow (current US$) of Low income in 2006 to that in 2010?
Offer a very short reply. 0.32. What is the ratio of the Aid flow (current US$) in Haiti in 2006 to that in 2010?
Give a very brief answer. 1.45. What is the ratio of the Aid flow (current US$) in Fragile and conflict affected situations in 2006 to that in 2011?
Make the answer very short. 1.58. What is the ratio of the Aid flow (current US$) of High income: OECD in 2006 to that in 2011?
Provide a short and direct response. 1. What is the ratio of the Aid flow (current US$) of Low income in 2006 to that in 2011?
Provide a short and direct response. 0.2. What is the ratio of the Aid flow (current US$) in Haiti in 2006 to that in 2011?
Keep it short and to the point. 0.34. What is the ratio of the Aid flow (current US$) of Fragile and conflict affected situations in 2006 to that in 2012?
Your answer should be very brief. 2.21. What is the ratio of the Aid flow (current US$) of Low income in 2006 to that in 2012?
Ensure brevity in your answer.  0.5. What is the ratio of the Aid flow (current US$) of Fragile and conflict affected situations in 2007 to that in 2008?
Give a very brief answer. 0.91. What is the ratio of the Aid flow (current US$) of High income: OECD in 2007 to that in 2008?
Ensure brevity in your answer.  1.3. What is the ratio of the Aid flow (current US$) in Low income in 2007 to that in 2008?
Make the answer very short. 0.83. What is the ratio of the Aid flow (current US$) of Haiti in 2007 to that in 2008?
Your response must be concise. 0.94. What is the ratio of the Aid flow (current US$) in Fragile and conflict affected situations in 2007 to that in 2010?
Your answer should be very brief. 1.31. What is the ratio of the Aid flow (current US$) of Low income in 2007 to that in 2010?
Offer a very short reply. 0.36. What is the ratio of the Aid flow (current US$) of Haiti in 2007 to that in 2010?
Your answer should be very brief. 1.55. What is the ratio of the Aid flow (current US$) of Fragile and conflict affected situations in 2007 to that in 2011?
Ensure brevity in your answer.  2.01. What is the ratio of the Aid flow (current US$) of High income: OECD in 2007 to that in 2011?
Provide a short and direct response. 1.44. What is the ratio of the Aid flow (current US$) of Low income in 2007 to that in 2011?
Ensure brevity in your answer.  0.22. What is the ratio of the Aid flow (current US$) of Haiti in 2007 to that in 2011?
Provide a succinct answer. 0.36. What is the ratio of the Aid flow (current US$) in Fragile and conflict affected situations in 2007 to that in 2012?
Provide a short and direct response. 2.8. What is the ratio of the Aid flow (current US$) in High income: OECD in 2007 to that in 2012?
Offer a terse response. 1.86. What is the ratio of the Aid flow (current US$) in Low income in 2007 to that in 2012?
Make the answer very short. 0.56. What is the ratio of the Aid flow (current US$) in Fragile and conflict affected situations in 2008 to that in 2010?
Give a very brief answer. 1.45. What is the ratio of the Aid flow (current US$) in High income: OECD in 2008 to that in 2010?
Your answer should be compact. 2.5. What is the ratio of the Aid flow (current US$) of Low income in 2008 to that in 2010?
Offer a very short reply. 0.43. What is the ratio of the Aid flow (current US$) of Haiti in 2008 to that in 2010?
Keep it short and to the point. 1.64. What is the ratio of the Aid flow (current US$) of Fragile and conflict affected situations in 2008 to that in 2011?
Make the answer very short. 2.22. What is the ratio of the Aid flow (current US$) of Low income in 2008 to that in 2011?
Give a very brief answer. 0.26. What is the ratio of the Aid flow (current US$) in Haiti in 2008 to that in 2011?
Provide a succinct answer. 0.38. What is the ratio of the Aid flow (current US$) of Fragile and conflict affected situations in 2008 to that in 2012?
Make the answer very short. 3.09. What is the ratio of the Aid flow (current US$) of High income: OECD in 2008 to that in 2012?
Make the answer very short. 1.43. What is the ratio of the Aid flow (current US$) in Low income in 2008 to that in 2012?
Your answer should be compact. 0.67. What is the ratio of the Aid flow (current US$) of Fragile and conflict affected situations in 2010 to that in 2011?
Your response must be concise. 1.53. What is the ratio of the Aid flow (current US$) in High income: OECD in 2010 to that in 2011?
Give a very brief answer. 0.44. What is the ratio of the Aid flow (current US$) of Low income in 2010 to that in 2011?
Provide a succinct answer. 0.61. What is the ratio of the Aid flow (current US$) of Haiti in 2010 to that in 2011?
Provide a short and direct response. 0.23. What is the ratio of the Aid flow (current US$) of Fragile and conflict affected situations in 2010 to that in 2012?
Ensure brevity in your answer.  2.14. What is the ratio of the Aid flow (current US$) of High income: OECD in 2010 to that in 2012?
Your answer should be very brief. 0.57. What is the ratio of the Aid flow (current US$) of Low income in 2010 to that in 2012?
Provide a succinct answer. 1.56. What is the ratio of the Aid flow (current US$) of Fragile and conflict affected situations in 2011 to that in 2012?
Keep it short and to the point. 1.39. What is the ratio of the Aid flow (current US$) in High income: OECD in 2011 to that in 2012?
Offer a terse response. 1.29. What is the ratio of the Aid flow (current US$) of Low income in 2011 to that in 2012?
Give a very brief answer. 2.55. What is the ratio of the Aid flow (current US$) of Haiti in 2011 to that in 2012?
Your answer should be compact. 47. What is the difference between the highest and the second highest Aid flow (current US$) in Fragile and conflict affected situations?
Provide a succinct answer. 9.33e+06. What is the difference between the highest and the second highest Aid flow (current US$) in High income: OECD?
Offer a very short reply. 2.10e+05. What is the difference between the highest and the second highest Aid flow (current US$) of Low income?
Ensure brevity in your answer.  9.20e+07. What is the difference between the highest and the lowest Aid flow (current US$) in Fragile and conflict affected situations?
Offer a very short reply. 6.70e+07. What is the difference between the highest and the lowest Aid flow (current US$) in High income: OECD?
Offer a terse response. 3.00e+05. What is the difference between the highest and the lowest Aid flow (current US$) in Low income?
Keep it short and to the point. 1.97e+08. 